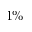Convert formula to latex. <formula><loc_0><loc_0><loc_500><loc_500>1 \%</formula> 